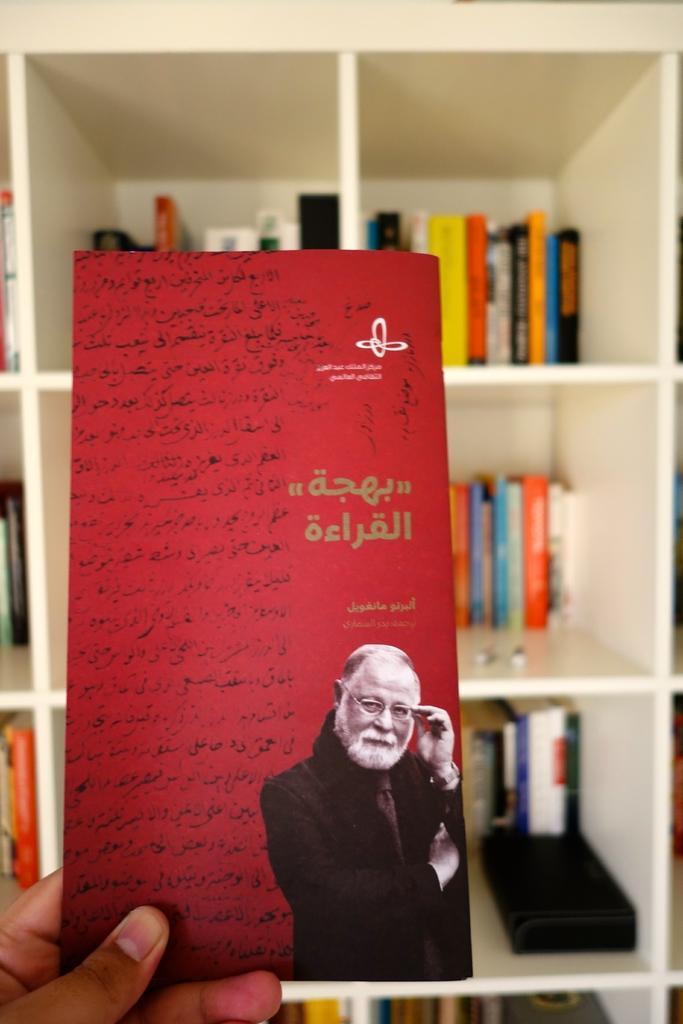Describe this image in one or two sentences. In this picture there is a card hold with hand of a person, on a card we can see a person and text. In the background of the image we can see books in racks. 